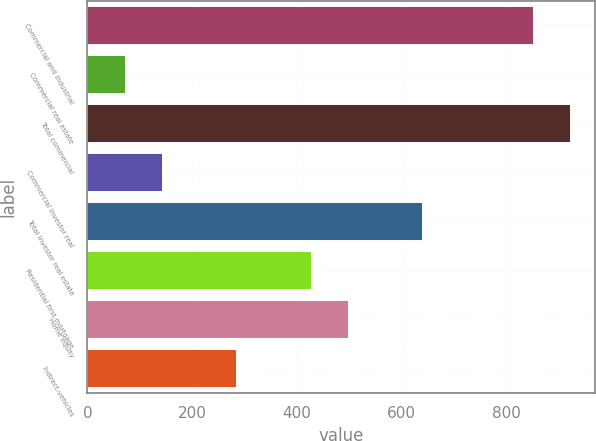Convert chart to OTSL. <chart><loc_0><loc_0><loc_500><loc_500><bar_chart><fcel>Commercial and industrial<fcel>Commercial real estate<fcel>Total commercial<fcel>Commercial investor real<fcel>Total investor real estate<fcel>Residential first mortgage<fcel>Home equity<fcel>Indirect-vehicles<nl><fcel>852.6<fcel>73.8<fcel>923.4<fcel>144.6<fcel>640.2<fcel>427.8<fcel>498.6<fcel>286.2<nl></chart> 